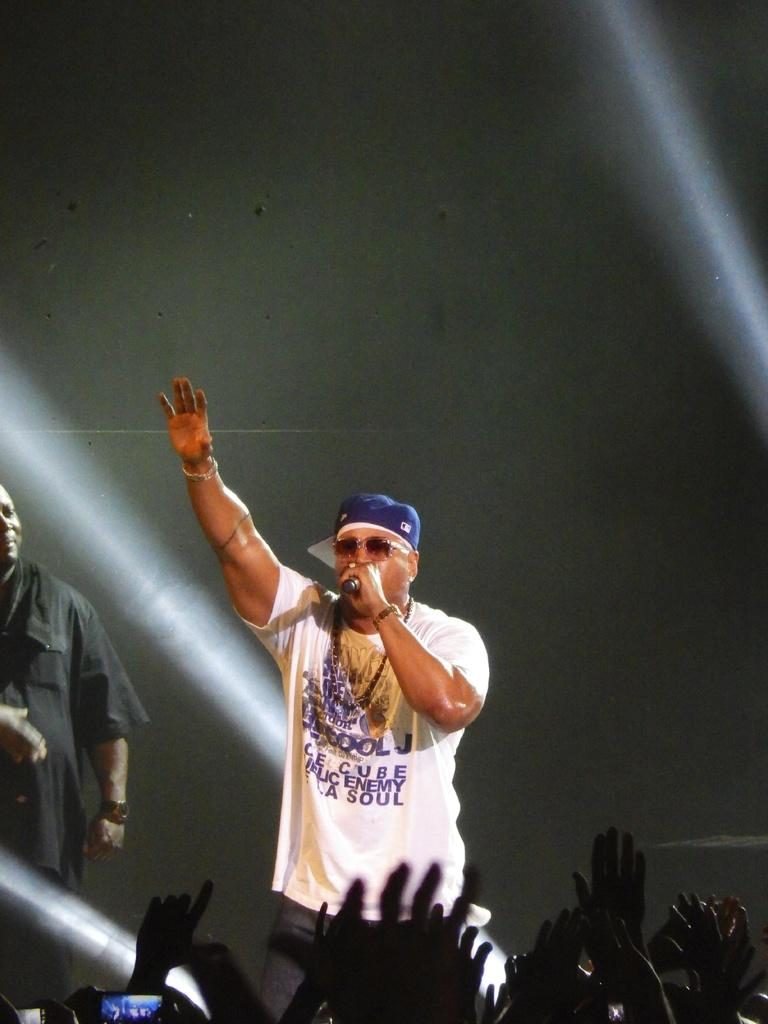<image>
Create a compact narrative representing the image presented. A singer is on stage wearing a LL Cool J T-shirt that says Ice Cube is Public Enemy one LA SOUL.. 